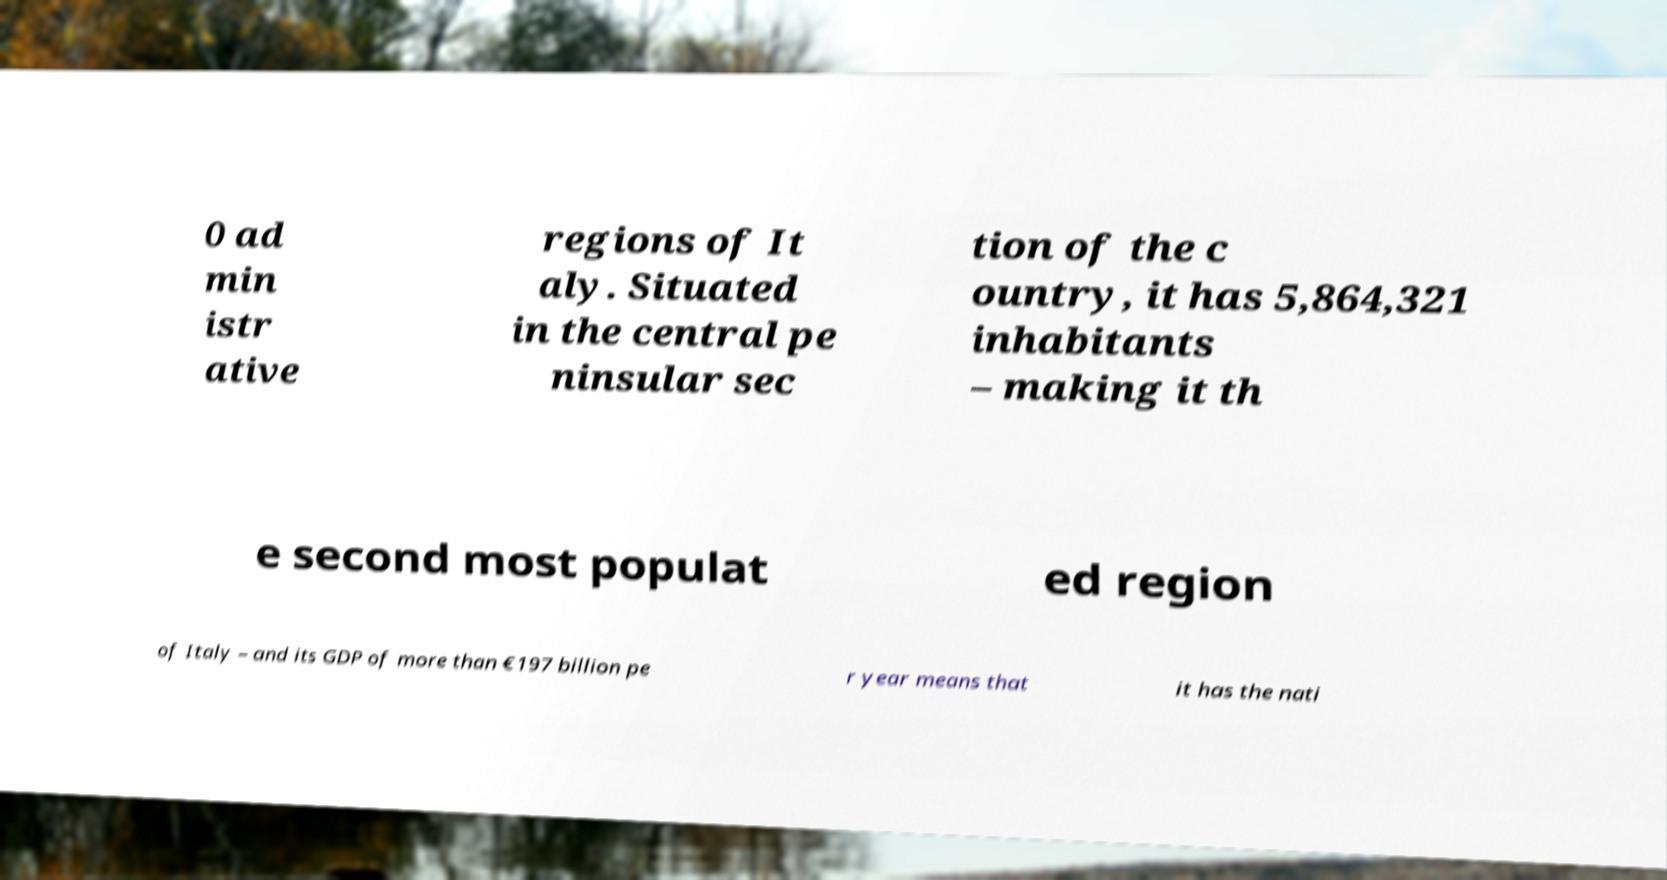For documentation purposes, I need the text within this image transcribed. Could you provide that? 0 ad min istr ative regions of It aly. Situated in the central pe ninsular sec tion of the c ountry, it has 5,864,321 inhabitants – making it th e second most populat ed region of Italy – and its GDP of more than €197 billion pe r year means that it has the nati 